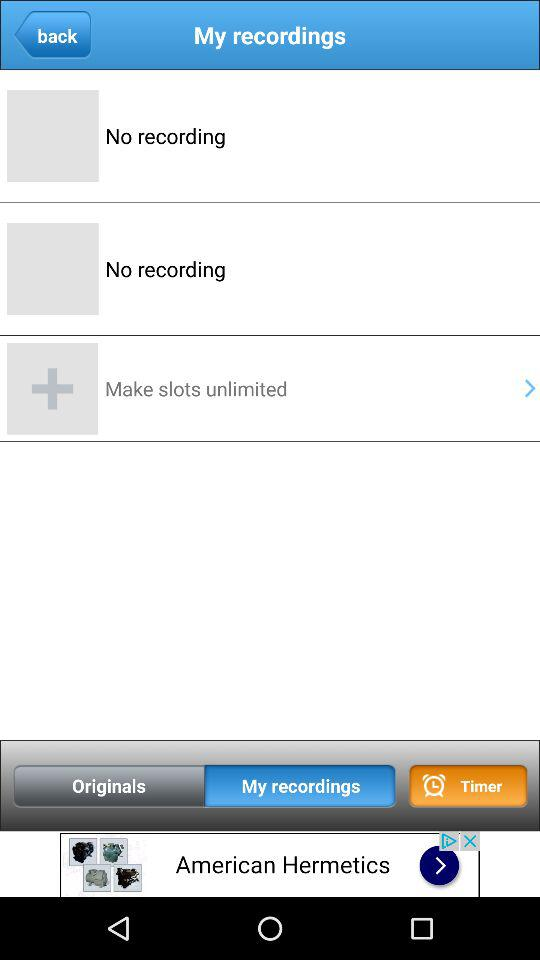Which tab is selected? The selected tab is "My recordings". 